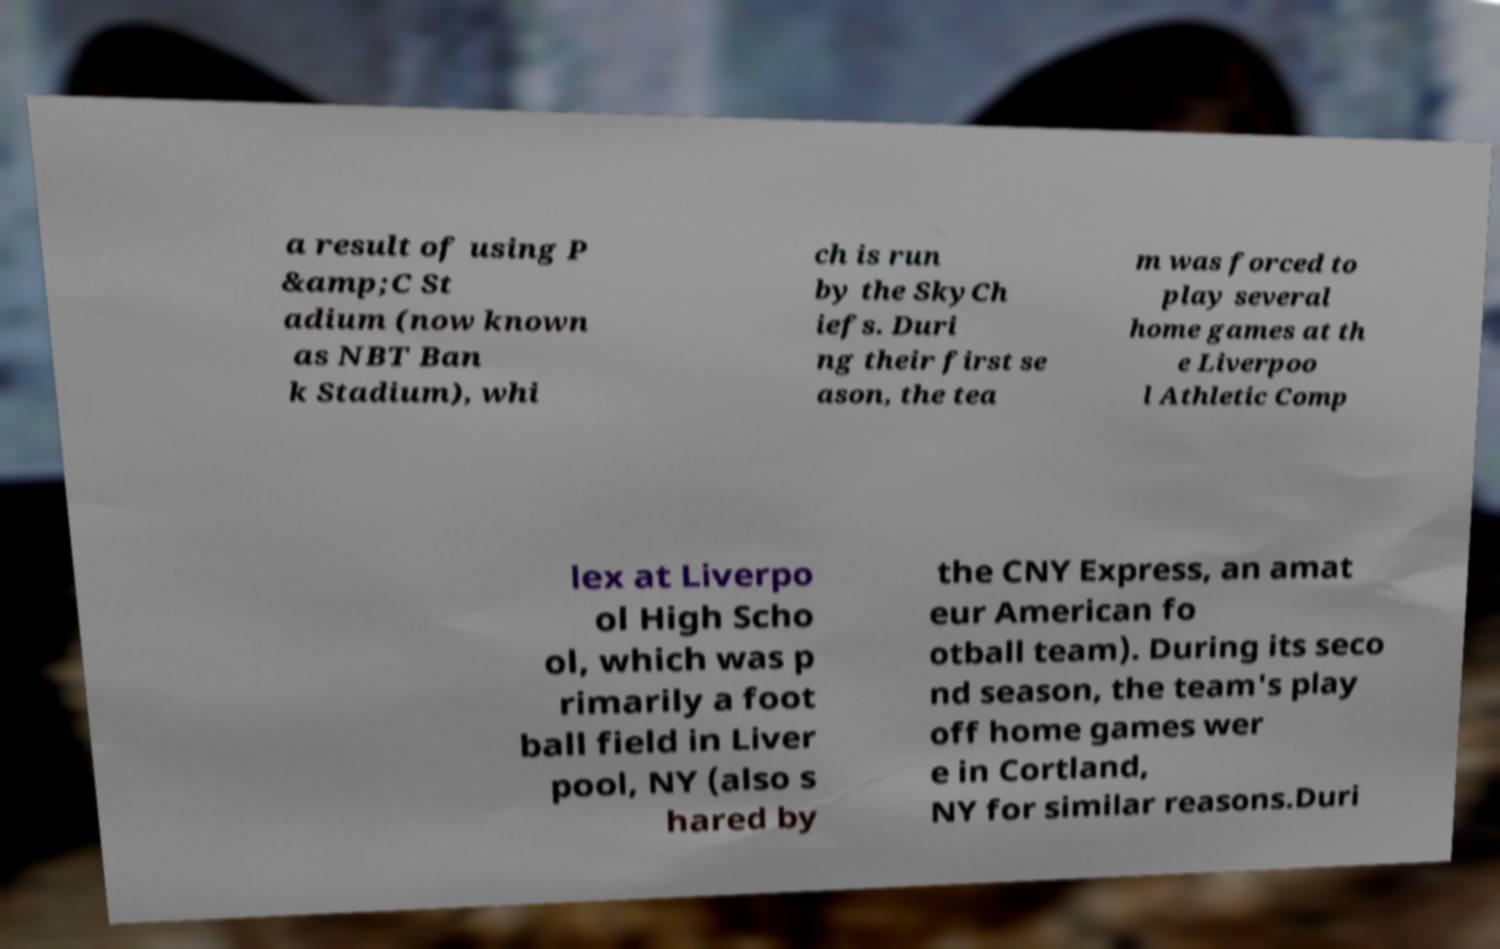Could you extract and type out the text from this image? a result of using P &amp;C St adium (now known as NBT Ban k Stadium), whi ch is run by the SkyCh iefs. Duri ng their first se ason, the tea m was forced to play several home games at th e Liverpoo l Athletic Comp lex at Liverpo ol High Scho ol, which was p rimarily a foot ball field in Liver pool, NY (also s hared by the CNY Express, an amat eur American fo otball team). During its seco nd season, the team's play off home games wer e in Cortland, NY for similar reasons.Duri 